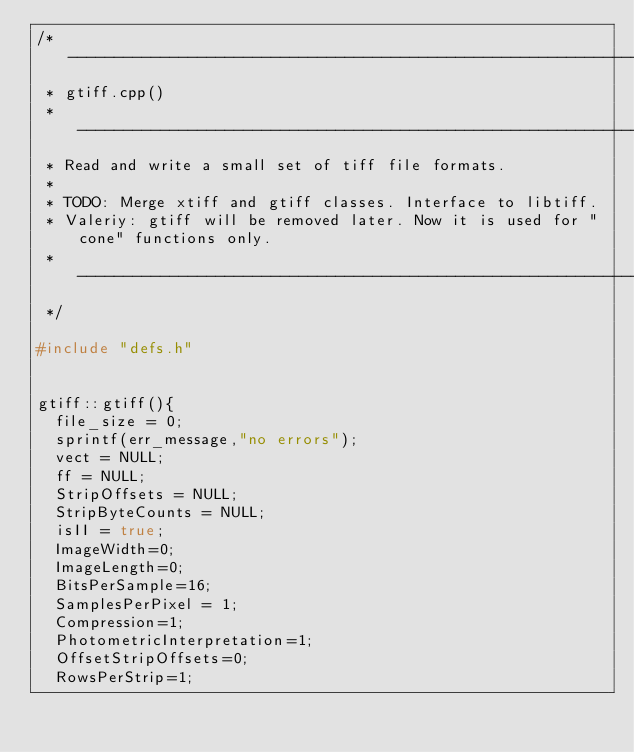Convert code to text. <code><loc_0><loc_0><loc_500><loc_500><_C++_>/* ----------------------------------------------------------------------
 * gtiff.cpp()
 * ----------------------------------------------------------------------
 * Read and write a small set of tiff file formats.
 *
 * TODO: Merge xtiff and gtiff classes. Interface to libtiff.
 * Valeriy: gtiff will be removed later. Now it is used for "cone" functions only.
 * ----------------------------------------------------------------------
 */

#include "defs.h"


gtiff::gtiff(){
	file_size = 0;
	sprintf(err_message,"no errors");
	vect = NULL;
	ff = NULL;
	StripOffsets = NULL;
	StripByteCounts = NULL;
	isII = true;
	ImageWidth=0;
	ImageLength=0;
	BitsPerSample=16;
	SamplesPerPixel = 1;
	Compression=1;
	PhotometricInterpretation=1;
	OffsetStripOffsets=0;
	RowsPerStrip=1;</code> 